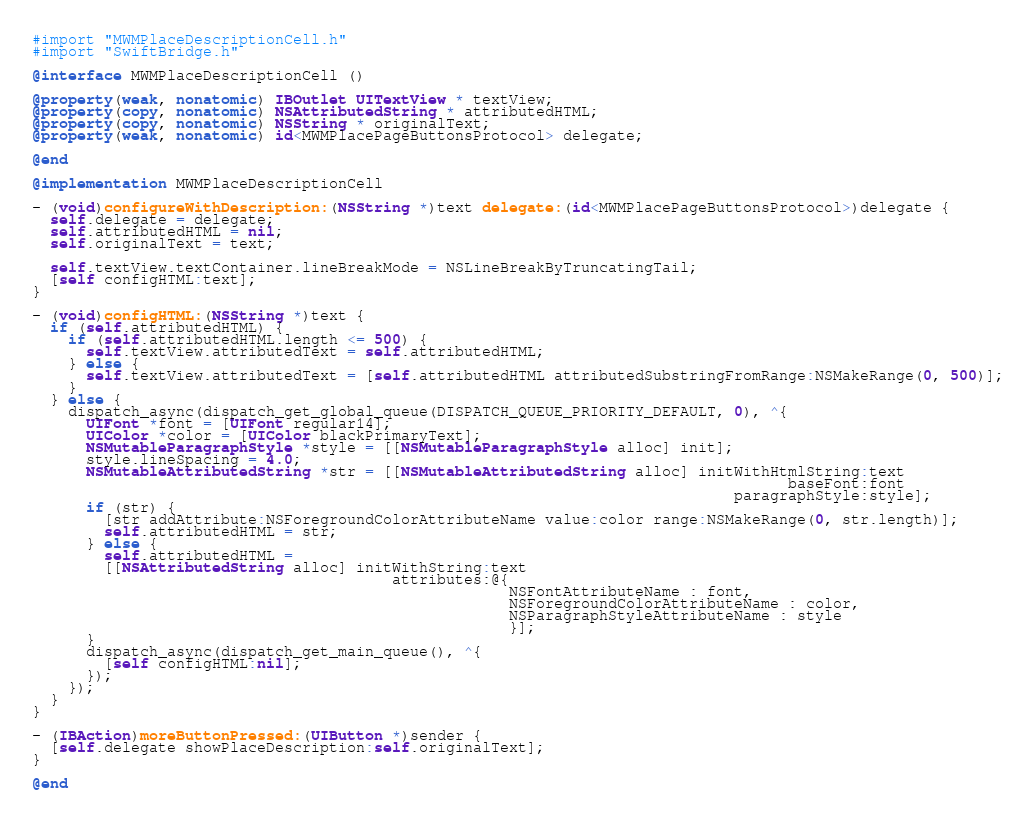Convert code to text. <code><loc_0><loc_0><loc_500><loc_500><_ObjectiveC_>#import "MWMPlaceDescriptionCell.h"
#import "SwiftBridge.h"

@interface MWMPlaceDescriptionCell ()

@property(weak, nonatomic) IBOutlet UITextView * textView;
@property(copy, nonatomic) NSAttributedString * attributedHTML;
@property(copy, nonatomic) NSString * originalText;
@property(weak, nonatomic) id<MWMPlacePageButtonsProtocol> delegate;

@end

@implementation MWMPlaceDescriptionCell

- (void)configureWithDescription:(NSString *)text delegate:(id<MWMPlacePageButtonsProtocol>)delegate {
  self.delegate = delegate;
  self.attributedHTML = nil;
  self.originalText = text;
  
  self.textView.textContainer.lineBreakMode = NSLineBreakByTruncatingTail;
  [self configHTML:text];
}

- (void)configHTML:(NSString *)text {
  if (self.attributedHTML) {
    if (self.attributedHTML.length <= 500) {
      self.textView.attributedText = self.attributedHTML;
    } else {
      self.textView.attributedText = [self.attributedHTML attributedSubstringFromRange:NSMakeRange(0, 500)];
    }
  } else {
    dispatch_async(dispatch_get_global_queue(DISPATCH_QUEUE_PRIORITY_DEFAULT, 0), ^{
      UIFont *font = [UIFont regular14];
      UIColor *color = [UIColor blackPrimaryText];
      NSMutableParagraphStyle *style = [[NSMutableParagraphStyle alloc] init];
      style.lineSpacing = 4.0;
      NSMutableAttributedString *str = [[NSMutableAttributedString alloc] initWithHtmlString:text
                                                                                    baseFont:font
                                                                              paragraphStyle:style];
      if (str) {
        [str addAttribute:NSForegroundColorAttributeName value:color range:NSMakeRange(0, str.length)];
        self.attributedHTML = str;
      } else {
        self.attributedHTML =
        [[NSAttributedString alloc] initWithString:text
                                        attributes:@{
                                                     NSFontAttributeName : font,
                                                     NSForegroundColorAttributeName : color,
                                                     NSParagraphStyleAttributeName : style
                                                     }];
      }
      dispatch_async(dispatch_get_main_queue(), ^{
        [self configHTML:nil];
      });
    });
  }
}

- (IBAction)moreButtonPressed:(UIButton *)sender {
  [self.delegate showPlaceDescription:self.originalText];
}

@end
</code> 